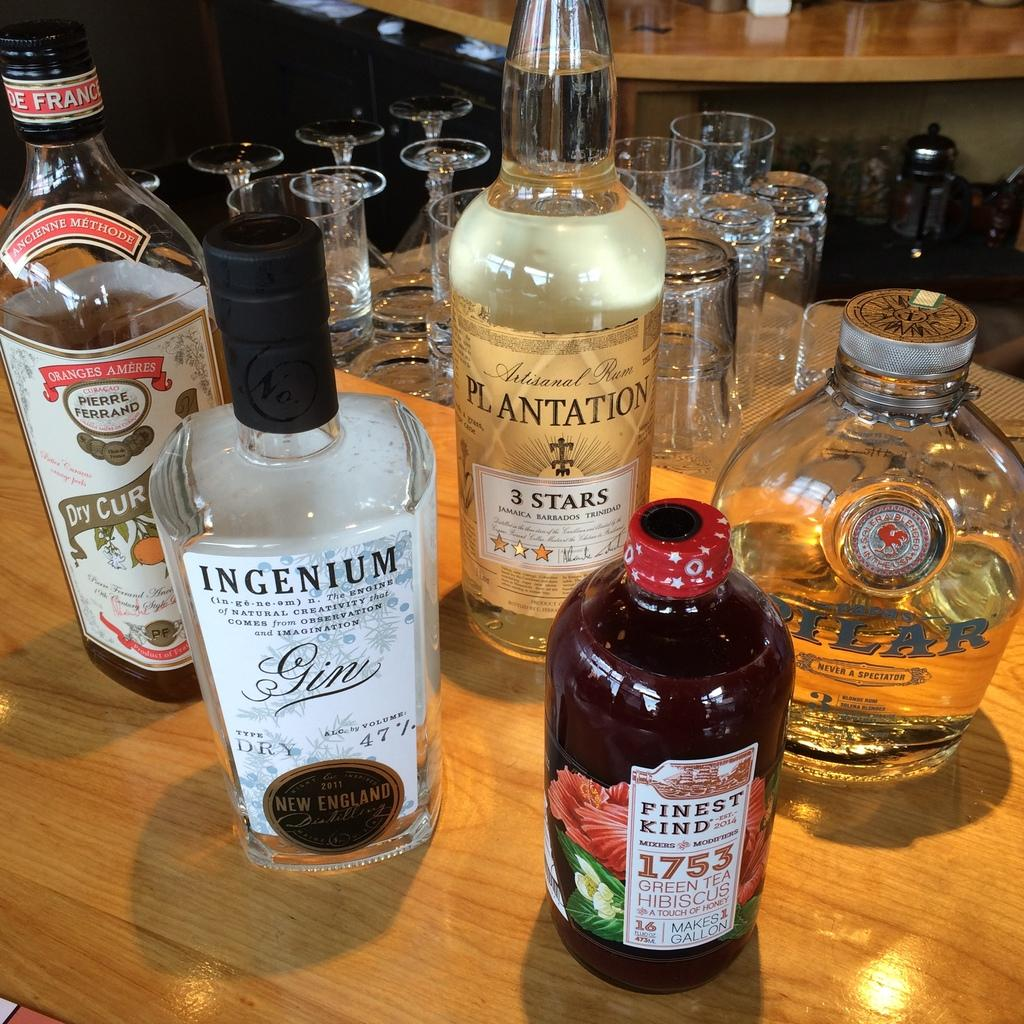<image>
Relay a brief, clear account of the picture shown. many alcohol bottles and one with France on it 